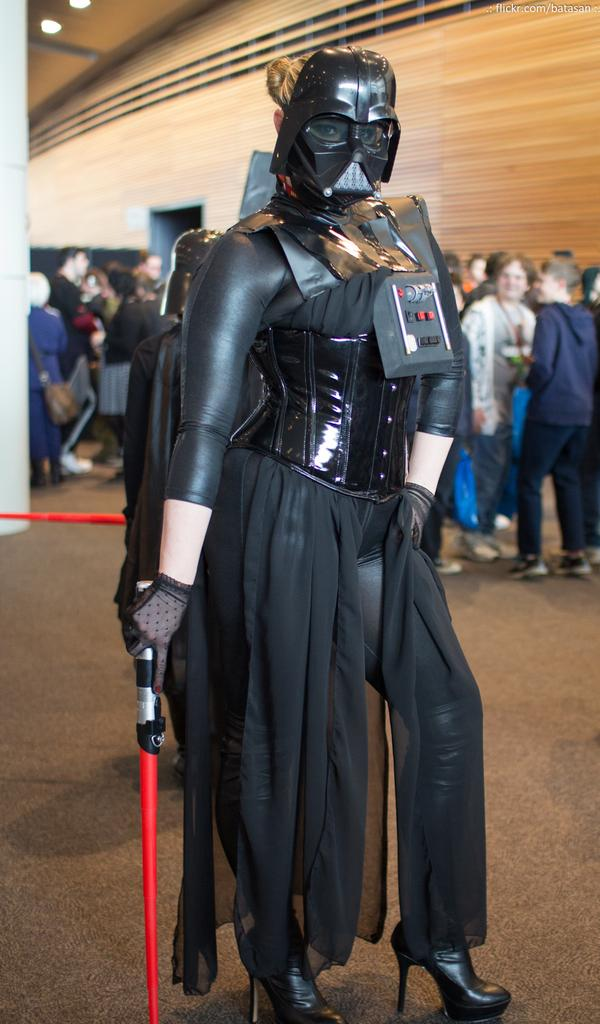What is the woman in the image wearing? The woman in the image is wearing a black dress. How is the woman positioned in the image? The woman is standing with her backside facing the viewer. Can you describe the actions of the other people in the image? Some of the people in the image are standing and talking to each other. Can you tell me how many goldfish are swimming in the woman's black dress in the image? There are no goldfish present in the image, and the woman's black dress is not depicted as containing any water or fish. 